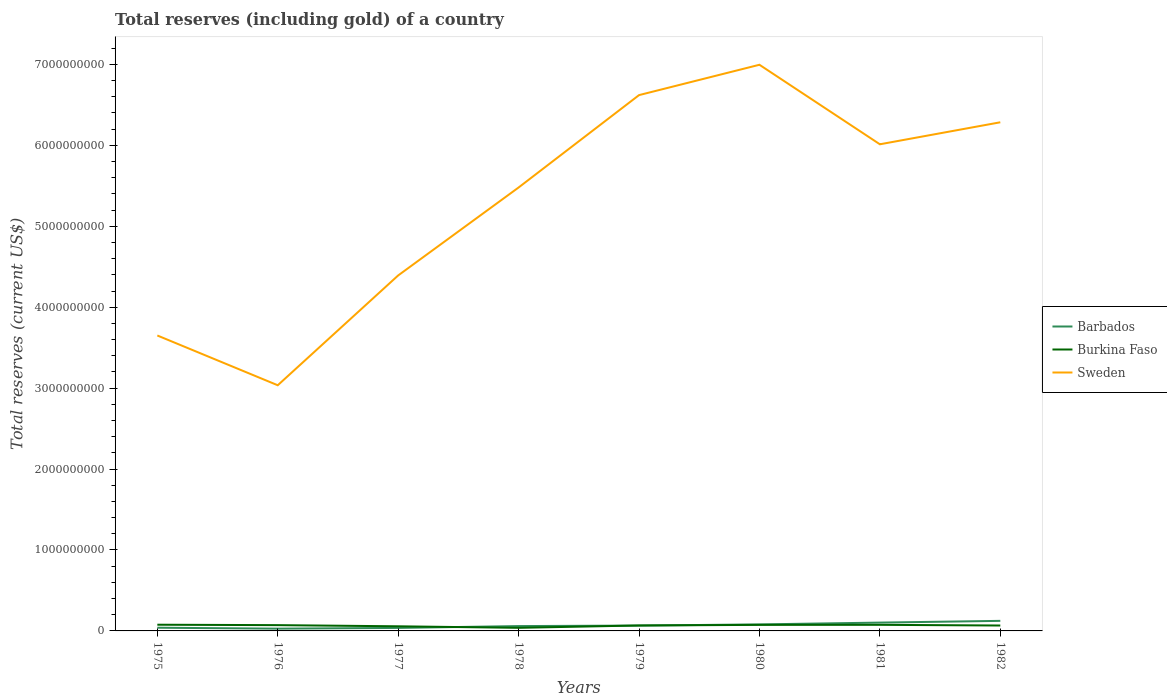Does the line corresponding to Sweden intersect with the line corresponding to Burkina Faso?
Provide a succinct answer. No. Is the number of lines equal to the number of legend labels?
Your answer should be compact. Yes. Across all years, what is the maximum total reserves (including gold) in Barbados?
Offer a very short reply. 2.80e+07. In which year was the total reserves (including gold) in Barbados maximum?
Your answer should be very brief. 1976. What is the total total reserves (including gold) in Barbados in the graph?
Your response must be concise. -8.74e+07. What is the difference between the highest and the second highest total reserves (including gold) in Sweden?
Give a very brief answer. 3.96e+09. What is the difference between the highest and the lowest total reserves (including gold) in Burkina Faso?
Your response must be concise. 6. How many lines are there?
Ensure brevity in your answer.  3. What is the difference between two consecutive major ticks on the Y-axis?
Make the answer very short. 1.00e+09. Does the graph contain any zero values?
Provide a short and direct response. No. Does the graph contain grids?
Give a very brief answer. No. What is the title of the graph?
Your response must be concise. Total reserves (including gold) of a country. What is the label or title of the X-axis?
Your answer should be very brief. Years. What is the label or title of the Y-axis?
Provide a succinct answer. Total reserves (current US$). What is the Total reserves (current US$) in Barbados in 1975?
Provide a short and direct response. 3.96e+07. What is the Total reserves (current US$) in Burkina Faso in 1975?
Your answer should be very brief. 7.65e+07. What is the Total reserves (current US$) of Sweden in 1975?
Ensure brevity in your answer.  3.65e+09. What is the Total reserves (current US$) in Barbados in 1976?
Your answer should be very brief. 2.80e+07. What is the Total reserves (current US$) of Burkina Faso in 1976?
Your answer should be compact. 7.14e+07. What is the Total reserves (current US$) of Sweden in 1976?
Ensure brevity in your answer.  3.04e+09. What is the Total reserves (current US$) of Barbados in 1977?
Keep it short and to the point. 3.70e+07. What is the Total reserves (current US$) of Burkina Faso in 1977?
Make the answer very short. 5.71e+07. What is the Total reserves (current US$) in Sweden in 1977?
Your answer should be compact. 4.39e+09. What is the Total reserves (current US$) of Barbados in 1978?
Your response must be concise. 5.98e+07. What is the Total reserves (current US$) in Burkina Faso in 1978?
Make the answer very short. 3.82e+07. What is the Total reserves (current US$) of Sweden in 1978?
Keep it short and to the point. 5.48e+09. What is the Total reserves (current US$) of Barbados in 1979?
Offer a terse response. 6.61e+07. What is the Total reserves (current US$) of Burkina Faso in 1979?
Provide a succinct answer. 6.73e+07. What is the Total reserves (current US$) in Sweden in 1979?
Offer a terse response. 6.62e+09. What is the Total reserves (current US$) of Barbados in 1980?
Your answer should be compact. 8.06e+07. What is the Total reserves (current US$) of Burkina Faso in 1980?
Provide a succinct answer. 7.48e+07. What is the Total reserves (current US$) in Sweden in 1980?
Offer a very short reply. 7.00e+09. What is the Total reserves (current US$) of Barbados in 1981?
Ensure brevity in your answer.  1.03e+08. What is the Total reserves (current US$) of Burkina Faso in 1981?
Your answer should be very brief. 7.53e+07. What is the Total reserves (current US$) in Sweden in 1981?
Make the answer very short. 6.01e+09. What is the Total reserves (current US$) of Barbados in 1982?
Ensure brevity in your answer.  1.24e+08. What is the Total reserves (current US$) of Burkina Faso in 1982?
Offer a very short reply. 6.69e+07. What is the Total reserves (current US$) in Sweden in 1982?
Your answer should be compact. 6.29e+09. Across all years, what is the maximum Total reserves (current US$) in Barbados?
Provide a succinct answer. 1.24e+08. Across all years, what is the maximum Total reserves (current US$) of Burkina Faso?
Your answer should be compact. 7.65e+07. Across all years, what is the maximum Total reserves (current US$) of Sweden?
Give a very brief answer. 7.00e+09. Across all years, what is the minimum Total reserves (current US$) of Barbados?
Offer a very short reply. 2.80e+07. Across all years, what is the minimum Total reserves (current US$) of Burkina Faso?
Make the answer very short. 3.82e+07. Across all years, what is the minimum Total reserves (current US$) of Sweden?
Provide a succinct answer. 3.04e+09. What is the total Total reserves (current US$) of Barbados in the graph?
Provide a short and direct response. 5.38e+08. What is the total Total reserves (current US$) of Burkina Faso in the graph?
Make the answer very short. 5.28e+08. What is the total Total reserves (current US$) of Sweden in the graph?
Ensure brevity in your answer.  4.25e+1. What is the difference between the Total reserves (current US$) of Barbados in 1975 and that in 1976?
Your answer should be compact. 1.16e+07. What is the difference between the Total reserves (current US$) of Burkina Faso in 1975 and that in 1976?
Your answer should be compact. 5.12e+06. What is the difference between the Total reserves (current US$) in Sweden in 1975 and that in 1976?
Keep it short and to the point. 6.15e+08. What is the difference between the Total reserves (current US$) of Barbados in 1975 and that in 1977?
Offer a very short reply. 2.57e+06. What is the difference between the Total reserves (current US$) in Burkina Faso in 1975 and that in 1977?
Your response must be concise. 1.94e+07. What is the difference between the Total reserves (current US$) in Sweden in 1975 and that in 1977?
Your response must be concise. -7.42e+08. What is the difference between the Total reserves (current US$) of Barbados in 1975 and that in 1978?
Your answer should be compact. -2.03e+07. What is the difference between the Total reserves (current US$) of Burkina Faso in 1975 and that in 1978?
Offer a terse response. 3.83e+07. What is the difference between the Total reserves (current US$) of Sweden in 1975 and that in 1978?
Provide a succinct answer. -1.83e+09. What is the difference between the Total reserves (current US$) in Barbados in 1975 and that in 1979?
Your response must be concise. -2.65e+07. What is the difference between the Total reserves (current US$) of Burkina Faso in 1975 and that in 1979?
Ensure brevity in your answer.  9.23e+06. What is the difference between the Total reserves (current US$) in Sweden in 1975 and that in 1979?
Offer a terse response. -2.97e+09. What is the difference between the Total reserves (current US$) of Barbados in 1975 and that in 1980?
Give a very brief answer. -4.10e+07. What is the difference between the Total reserves (current US$) in Burkina Faso in 1975 and that in 1980?
Offer a terse response. 1.76e+06. What is the difference between the Total reserves (current US$) of Sweden in 1975 and that in 1980?
Give a very brief answer. -3.35e+09. What is the difference between the Total reserves (current US$) of Barbados in 1975 and that in 1981?
Provide a short and direct response. -6.34e+07. What is the difference between the Total reserves (current US$) of Burkina Faso in 1975 and that in 1981?
Offer a terse response. 1.26e+06. What is the difference between the Total reserves (current US$) in Sweden in 1975 and that in 1981?
Your answer should be compact. -2.36e+09. What is the difference between the Total reserves (current US$) of Barbados in 1975 and that in 1982?
Your answer should be very brief. -8.48e+07. What is the difference between the Total reserves (current US$) in Burkina Faso in 1975 and that in 1982?
Make the answer very short. 9.68e+06. What is the difference between the Total reserves (current US$) in Sweden in 1975 and that in 1982?
Offer a terse response. -2.63e+09. What is the difference between the Total reserves (current US$) in Barbados in 1976 and that in 1977?
Ensure brevity in your answer.  -9.03e+06. What is the difference between the Total reserves (current US$) in Burkina Faso in 1976 and that in 1977?
Your answer should be very brief. 1.43e+07. What is the difference between the Total reserves (current US$) in Sweden in 1976 and that in 1977?
Ensure brevity in your answer.  -1.36e+09. What is the difference between the Total reserves (current US$) of Barbados in 1976 and that in 1978?
Your response must be concise. -3.19e+07. What is the difference between the Total reserves (current US$) in Burkina Faso in 1976 and that in 1978?
Provide a succinct answer. 3.32e+07. What is the difference between the Total reserves (current US$) of Sweden in 1976 and that in 1978?
Ensure brevity in your answer.  -2.44e+09. What is the difference between the Total reserves (current US$) of Barbados in 1976 and that in 1979?
Give a very brief answer. -3.81e+07. What is the difference between the Total reserves (current US$) in Burkina Faso in 1976 and that in 1979?
Your answer should be very brief. 4.11e+06. What is the difference between the Total reserves (current US$) in Sweden in 1976 and that in 1979?
Offer a very short reply. -3.59e+09. What is the difference between the Total reserves (current US$) of Barbados in 1976 and that in 1980?
Make the answer very short. -5.26e+07. What is the difference between the Total reserves (current US$) of Burkina Faso in 1976 and that in 1980?
Offer a very short reply. -3.37e+06. What is the difference between the Total reserves (current US$) in Sweden in 1976 and that in 1980?
Give a very brief answer. -3.96e+09. What is the difference between the Total reserves (current US$) in Barbados in 1976 and that in 1981?
Your response must be concise. -7.50e+07. What is the difference between the Total reserves (current US$) of Burkina Faso in 1976 and that in 1981?
Provide a short and direct response. -3.87e+06. What is the difference between the Total reserves (current US$) in Sweden in 1976 and that in 1981?
Your answer should be compact. -2.98e+09. What is the difference between the Total reserves (current US$) of Barbados in 1976 and that in 1982?
Ensure brevity in your answer.  -9.64e+07. What is the difference between the Total reserves (current US$) in Burkina Faso in 1976 and that in 1982?
Ensure brevity in your answer.  4.55e+06. What is the difference between the Total reserves (current US$) in Sweden in 1976 and that in 1982?
Provide a succinct answer. -3.25e+09. What is the difference between the Total reserves (current US$) of Barbados in 1977 and that in 1978?
Offer a very short reply. -2.28e+07. What is the difference between the Total reserves (current US$) of Burkina Faso in 1977 and that in 1978?
Your answer should be compact. 1.89e+07. What is the difference between the Total reserves (current US$) in Sweden in 1977 and that in 1978?
Ensure brevity in your answer.  -1.09e+09. What is the difference between the Total reserves (current US$) of Barbados in 1977 and that in 1979?
Offer a very short reply. -2.91e+07. What is the difference between the Total reserves (current US$) in Burkina Faso in 1977 and that in 1979?
Keep it short and to the point. -1.02e+07. What is the difference between the Total reserves (current US$) of Sweden in 1977 and that in 1979?
Your answer should be compact. -2.23e+09. What is the difference between the Total reserves (current US$) of Barbados in 1977 and that in 1980?
Your response must be concise. -4.36e+07. What is the difference between the Total reserves (current US$) in Burkina Faso in 1977 and that in 1980?
Provide a succinct answer. -1.76e+07. What is the difference between the Total reserves (current US$) in Sweden in 1977 and that in 1980?
Offer a terse response. -2.60e+09. What is the difference between the Total reserves (current US$) in Barbados in 1977 and that in 1981?
Offer a terse response. -6.60e+07. What is the difference between the Total reserves (current US$) of Burkina Faso in 1977 and that in 1981?
Give a very brief answer. -1.81e+07. What is the difference between the Total reserves (current US$) of Sweden in 1977 and that in 1981?
Ensure brevity in your answer.  -1.62e+09. What is the difference between the Total reserves (current US$) in Barbados in 1977 and that in 1982?
Offer a terse response. -8.74e+07. What is the difference between the Total reserves (current US$) of Burkina Faso in 1977 and that in 1982?
Offer a terse response. -9.73e+06. What is the difference between the Total reserves (current US$) of Sweden in 1977 and that in 1982?
Your answer should be very brief. -1.89e+09. What is the difference between the Total reserves (current US$) of Barbados in 1978 and that in 1979?
Provide a succinct answer. -6.28e+06. What is the difference between the Total reserves (current US$) of Burkina Faso in 1978 and that in 1979?
Offer a very short reply. -2.91e+07. What is the difference between the Total reserves (current US$) of Sweden in 1978 and that in 1979?
Your response must be concise. -1.14e+09. What is the difference between the Total reserves (current US$) in Barbados in 1978 and that in 1980?
Offer a terse response. -2.07e+07. What is the difference between the Total reserves (current US$) in Burkina Faso in 1978 and that in 1980?
Ensure brevity in your answer.  -3.66e+07. What is the difference between the Total reserves (current US$) in Sweden in 1978 and that in 1980?
Make the answer very short. -1.52e+09. What is the difference between the Total reserves (current US$) of Barbados in 1978 and that in 1981?
Keep it short and to the point. -4.31e+07. What is the difference between the Total reserves (current US$) of Burkina Faso in 1978 and that in 1981?
Provide a short and direct response. -3.71e+07. What is the difference between the Total reserves (current US$) in Sweden in 1978 and that in 1981?
Offer a very short reply. -5.34e+08. What is the difference between the Total reserves (current US$) of Barbados in 1978 and that in 1982?
Your response must be concise. -6.45e+07. What is the difference between the Total reserves (current US$) of Burkina Faso in 1978 and that in 1982?
Provide a short and direct response. -2.87e+07. What is the difference between the Total reserves (current US$) of Sweden in 1978 and that in 1982?
Keep it short and to the point. -8.06e+08. What is the difference between the Total reserves (current US$) of Barbados in 1979 and that in 1980?
Your response must be concise. -1.45e+07. What is the difference between the Total reserves (current US$) of Burkina Faso in 1979 and that in 1980?
Your answer should be compact. -7.48e+06. What is the difference between the Total reserves (current US$) in Sweden in 1979 and that in 1980?
Your answer should be very brief. -3.75e+08. What is the difference between the Total reserves (current US$) of Barbados in 1979 and that in 1981?
Your answer should be very brief. -3.68e+07. What is the difference between the Total reserves (current US$) in Burkina Faso in 1979 and that in 1981?
Make the answer very short. -7.98e+06. What is the difference between the Total reserves (current US$) of Sweden in 1979 and that in 1981?
Offer a very short reply. 6.08e+08. What is the difference between the Total reserves (current US$) of Barbados in 1979 and that in 1982?
Your answer should be compact. -5.83e+07. What is the difference between the Total reserves (current US$) of Burkina Faso in 1979 and that in 1982?
Ensure brevity in your answer.  4.41e+05. What is the difference between the Total reserves (current US$) in Sweden in 1979 and that in 1982?
Offer a very short reply. 3.36e+08. What is the difference between the Total reserves (current US$) of Barbados in 1980 and that in 1981?
Your answer should be compact. -2.24e+07. What is the difference between the Total reserves (current US$) of Burkina Faso in 1980 and that in 1981?
Offer a very short reply. -4.99e+05. What is the difference between the Total reserves (current US$) in Sweden in 1980 and that in 1981?
Your answer should be compact. 9.83e+08. What is the difference between the Total reserves (current US$) in Barbados in 1980 and that in 1982?
Provide a short and direct response. -4.38e+07. What is the difference between the Total reserves (current US$) of Burkina Faso in 1980 and that in 1982?
Offer a very short reply. 7.92e+06. What is the difference between the Total reserves (current US$) in Sweden in 1980 and that in 1982?
Keep it short and to the point. 7.11e+08. What is the difference between the Total reserves (current US$) in Barbados in 1981 and that in 1982?
Offer a very short reply. -2.14e+07. What is the difference between the Total reserves (current US$) in Burkina Faso in 1981 and that in 1982?
Offer a very short reply. 8.42e+06. What is the difference between the Total reserves (current US$) in Sweden in 1981 and that in 1982?
Provide a short and direct response. -2.72e+08. What is the difference between the Total reserves (current US$) in Barbados in 1975 and the Total reserves (current US$) in Burkina Faso in 1976?
Ensure brevity in your answer.  -3.18e+07. What is the difference between the Total reserves (current US$) in Barbados in 1975 and the Total reserves (current US$) in Sweden in 1976?
Keep it short and to the point. -3.00e+09. What is the difference between the Total reserves (current US$) in Burkina Faso in 1975 and the Total reserves (current US$) in Sweden in 1976?
Provide a succinct answer. -2.96e+09. What is the difference between the Total reserves (current US$) in Barbados in 1975 and the Total reserves (current US$) in Burkina Faso in 1977?
Offer a very short reply. -1.76e+07. What is the difference between the Total reserves (current US$) of Barbados in 1975 and the Total reserves (current US$) of Sweden in 1977?
Provide a succinct answer. -4.35e+09. What is the difference between the Total reserves (current US$) of Burkina Faso in 1975 and the Total reserves (current US$) of Sweden in 1977?
Provide a short and direct response. -4.32e+09. What is the difference between the Total reserves (current US$) of Barbados in 1975 and the Total reserves (current US$) of Burkina Faso in 1978?
Keep it short and to the point. 1.36e+06. What is the difference between the Total reserves (current US$) of Barbados in 1975 and the Total reserves (current US$) of Sweden in 1978?
Keep it short and to the point. -5.44e+09. What is the difference between the Total reserves (current US$) in Burkina Faso in 1975 and the Total reserves (current US$) in Sweden in 1978?
Make the answer very short. -5.40e+09. What is the difference between the Total reserves (current US$) in Barbados in 1975 and the Total reserves (current US$) in Burkina Faso in 1979?
Give a very brief answer. -2.77e+07. What is the difference between the Total reserves (current US$) in Barbados in 1975 and the Total reserves (current US$) in Sweden in 1979?
Your response must be concise. -6.58e+09. What is the difference between the Total reserves (current US$) in Burkina Faso in 1975 and the Total reserves (current US$) in Sweden in 1979?
Provide a succinct answer. -6.54e+09. What is the difference between the Total reserves (current US$) of Barbados in 1975 and the Total reserves (current US$) of Burkina Faso in 1980?
Provide a succinct answer. -3.52e+07. What is the difference between the Total reserves (current US$) of Barbados in 1975 and the Total reserves (current US$) of Sweden in 1980?
Offer a very short reply. -6.96e+09. What is the difference between the Total reserves (current US$) of Burkina Faso in 1975 and the Total reserves (current US$) of Sweden in 1980?
Provide a short and direct response. -6.92e+09. What is the difference between the Total reserves (current US$) in Barbados in 1975 and the Total reserves (current US$) in Burkina Faso in 1981?
Your answer should be compact. -3.57e+07. What is the difference between the Total reserves (current US$) of Barbados in 1975 and the Total reserves (current US$) of Sweden in 1981?
Keep it short and to the point. -5.97e+09. What is the difference between the Total reserves (current US$) of Burkina Faso in 1975 and the Total reserves (current US$) of Sweden in 1981?
Your response must be concise. -5.94e+09. What is the difference between the Total reserves (current US$) in Barbados in 1975 and the Total reserves (current US$) in Burkina Faso in 1982?
Provide a succinct answer. -2.73e+07. What is the difference between the Total reserves (current US$) in Barbados in 1975 and the Total reserves (current US$) in Sweden in 1982?
Provide a short and direct response. -6.25e+09. What is the difference between the Total reserves (current US$) in Burkina Faso in 1975 and the Total reserves (current US$) in Sweden in 1982?
Your answer should be compact. -6.21e+09. What is the difference between the Total reserves (current US$) in Barbados in 1976 and the Total reserves (current US$) in Burkina Faso in 1977?
Provide a succinct answer. -2.92e+07. What is the difference between the Total reserves (current US$) in Barbados in 1976 and the Total reserves (current US$) in Sweden in 1977?
Provide a short and direct response. -4.36e+09. What is the difference between the Total reserves (current US$) of Burkina Faso in 1976 and the Total reserves (current US$) of Sweden in 1977?
Make the answer very short. -4.32e+09. What is the difference between the Total reserves (current US$) in Barbados in 1976 and the Total reserves (current US$) in Burkina Faso in 1978?
Your answer should be compact. -1.02e+07. What is the difference between the Total reserves (current US$) in Barbados in 1976 and the Total reserves (current US$) in Sweden in 1978?
Your answer should be compact. -5.45e+09. What is the difference between the Total reserves (current US$) in Burkina Faso in 1976 and the Total reserves (current US$) in Sweden in 1978?
Your answer should be compact. -5.41e+09. What is the difference between the Total reserves (current US$) of Barbados in 1976 and the Total reserves (current US$) of Burkina Faso in 1979?
Ensure brevity in your answer.  -3.93e+07. What is the difference between the Total reserves (current US$) in Barbados in 1976 and the Total reserves (current US$) in Sweden in 1979?
Keep it short and to the point. -6.59e+09. What is the difference between the Total reserves (current US$) of Burkina Faso in 1976 and the Total reserves (current US$) of Sweden in 1979?
Offer a terse response. -6.55e+09. What is the difference between the Total reserves (current US$) in Barbados in 1976 and the Total reserves (current US$) in Burkina Faso in 1980?
Make the answer very short. -4.68e+07. What is the difference between the Total reserves (current US$) of Barbados in 1976 and the Total reserves (current US$) of Sweden in 1980?
Your response must be concise. -6.97e+09. What is the difference between the Total reserves (current US$) of Burkina Faso in 1976 and the Total reserves (current US$) of Sweden in 1980?
Provide a short and direct response. -6.92e+09. What is the difference between the Total reserves (current US$) of Barbados in 1976 and the Total reserves (current US$) of Burkina Faso in 1981?
Give a very brief answer. -4.73e+07. What is the difference between the Total reserves (current US$) of Barbados in 1976 and the Total reserves (current US$) of Sweden in 1981?
Offer a very short reply. -5.99e+09. What is the difference between the Total reserves (current US$) of Burkina Faso in 1976 and the Total reserves (current US$) of Sweden in 1981?
Your answer should be compact. -5.94e+09. What is the difference between the Total reserves (current US$) of Barbados in 1976 and the Total reserves (current US$) of Burkina Faso in 1982?
Keep it short and to the point. -3.89e+07. What is the difference between the Total reserves (current US$) of Barbados in 1976 and the Total reserves (current US$) of Sweden in 1982?
Keep it short and to the point. -6.26e+09. What is the difference between the Total reserves (current US$) in Burkina Faso in 1976 and the Total reserves (current US$) in Sweden in 1982?
Provide a succinct answer. -6.21e+09. What is the difference between the Total reserves (current US$) of Barbados in 1977 and the Total reserves (current US$) of Burkina Faso in 1978?
Ensure brevity in your answer.  -1.21e+06. What is the difference between the Total reserves (current US$) of Barbados in 1977 and the Total reserves (current US$) of Sweden in 1978?
Your answer should be compact. -5.44e+09. What is the difference between the Total reserves (current US$) in Burkina Faso in 1977 and the Total reserves (current US$) in Sweden in 1978?
Provide a short and direct response. -5.42e+09. What is the difference between the Total reserves (current US$) of Barbados in 1977 and the Total reserves (current US$) of Burkina Faso in 1979?
Your response must be concise. -3.03e+07. What is the difference between the Total reserves (current US$) in Barbados in 1977 and the Total reserves (current US$) in Sweden in 1979?
Ensure brevity in your answer.  -6.58e+09. What is the difference between the Total reserves (current US$) of Burkina Faso in 1977 and the Total reserves (current US$) of Sweden in 1979?
Your answer should be compact. -6.56e+09. What is the difference between the Total reserves (current US$) of Barbados in 1977 and the Total reserves (current US$) of Burkina Faso in 1980?
Your answer should be compact. -3.78e+07. What is the difference between the Total reserves (current US$) in Barbados in 1977 and the Total reserves (current US$) in Sweden in 1980?
Provide a succinct answer. -6.96e+09. What is the difference between the Total reserves (current US$) of Burkina Faso in 1977 and the Total reserves (current US$) of Sweden in 1980?
Make the answer very short. -6.94e+09. What is the difference between the Total reserves (current US$) of Barbados in 1977 and the Total reserves (current US$) of Burkina Faso in 1981?
Ensure brevity in your answer.  -3.83e+07. What is the difference between the Total reserves (current US$) of Barbados in 1977 and the Total reserves (current US$) of Sweden in 1981?
Make the answer very short. -5.98e+09. What is the difference between the Total reserves (current US$) in Burkina Faso in 1977 and the Total reserves (current US$) in Sweden in 1981?
Make the answer very short. -5.96e+09. What is the difference between the Total reserves (current US$) in Barbados in 1977 and the Total reserves (current US$) in Burkina Faso in 1982?
Your response must be concise. -2.99e+07. What is the difference between the Total reserves (current US$) in Barbados in 1977 and the Total reserves (current US$) in Sweden in 1982?
Provide a succinct answer. -6.25e+09. What is the difference between the Total reserves (current US$) in Burkina Faso in 1977 and the Total reserves (current US$) in Sweden in 1982?
Give a very brief answer. -6.23e+09. What is the difference between the Total reserves (current US$) of Barbados in 1978 and the Total reserves (current US$) of Burkina Faso in 1979?
Offer a terse response. -7.48e+06. What is the difference between the Total reserves (current US$) of Barbados in 1978 and the Total reserves (current US$) of Sweden in 1979?
Offer a terse response. -6.56e+09. What is the difference between the Total reserves (current US$) of Burkina Faso in 1978 and the Total reserves (current US$) of Sweden in 1979?
Your answer should be compact. -6.58e+09. What is the difference between the Total reserves (current US$) in Barbados in 1978 and the Total reserves (current US$) in Burkina Faso in 1980?
Make the answer very short. -1.50e+07. What is the difference between the Total reserves (current US$) in Barbados in 1978 and the Total reserves (current US$) in Sweden in 1980?
Keep it short and to the point. -6.94e+09. What is the difference between the Total reserves (current US$) of Burkina Faso in 1978 and the Total reserves (current US$) of Sweden in 1980?
Provide a short and direct response. -6.96e+09. What is the difference between the Total reserves (current US$) in Barbados in 1978 and the Total reserves (current US$) in Burkina Faso in 1981?
Offer a terse response. -1.55e+07. What is the difference between the Total reserves (current US$) in Barbados in 1978 and the Total reserves (current US$) in Sweden in 1981?
Offer a terse response. -5.95e+09. What is the difference between the Total reserves (current US$) of Burkina Faso in 1978 and the Total reserves (current US$) of Sweden in 1981?
Offer a very short reply. -5.98e+09. What is the difference between the Total reserves (current US$) in Barbados in 1978 and the Total reserves (current US$) in Burkina Faso in 1982?
Give a very brief answer. -7.04e+06. What is the difference between the Total reserves (current US$) of Barbados in 1978 and the Total reserves (current US$) of Sweden in 1982?
Offer a terse response. -6.23e+09. What is the difference between the Total reserves (current US$) of Burkina Faso in 1978 and the Total reserves (current US$) of Sweden in 1982?
Your answer should be very brief. -6.25e+09. What is the difference between the Total reserves (current US$) in Barbados in 1979 and the Total reserves (current US$) in Burkina Faso in 1980?
Make the answer very short. -8.67e+06. What is the difference between the Total reserves (current US$) of Barbados in 1979 and the Total reserves (current US$) of Sweden in 1980?
Make the answer very short. -6.93e+09. What is the difference between the Total reserves (current US$) in Burkina Faso in 1979 and the Total reserves (current US$) in Sweden in 1980?
Your answer should be very brief. -6.93e+09. What is the difference between the Total reserves (current US$) in Barbados in 1979 and the Total reserves (current US$) in Burkina Faso in 1981?
Your answer should be very brief. -9.17e+06. What is the difference between the Total reserves (current US$) in Barbados in 1979 and the Total reserves (current US$) in Sweden in 1981?
Offer a terse response. -5.95e+09. What is the difference between the Total reserves (current US$) of Burkina Faso in 1979 and the Total reserves (current US$) of Sweden in 1981?
Offer a terse response. -5.95e+09. What is the difference between the Total reserves (current US$) in Barbados in 1979 and the Total reserves (current US$) in Burkina Faso in 1982?
Make the answer very short. -7.56e+05. What is the difference between the Total reserves (current US$) of Barbados in 1979 and the Total reserves (current US$) of Sweden in 1982?
Make the answer very short. -6.22e+09. What is the difference between the Total reserves (current US$) of Burkina Faso in 1979 and the Total reserves (current US$) of Sweden in 1982?
Provide a succinct answer. -6.22e+09. What is the difference between the Total reserves (current US$) of Barbados in 1980 and the Total reserves (current US$) of Burkina Faso in 1981?
Your answer should be very brief. 5.28e+06. What is the difference between the Total reserves (current US$) in Barbados in 1980 and the Total reserves (current US$) in Sweden in 1981?
Make the answer very short. -5.93e+09. What is the difference between the Total reserves (current US$) of Burkina Faso in 1980 and the Total reserves (current US$) of Sweden in 1981?
Make the answer very short. -5.94e+09. What is the difference between the Total reserves (current US$) in Barbados in 1980 and the Total reserves (current US$) in Burkina Faso in 1982?
Offer a very short reply. 1.37e+07. What is the difference between the Total reserves (current US$) of Barbados in 1980 and the Total reserves (current US$) of Sweden in 1982?
Ensure brevity in your answer.  -6.20e+09. What is the difference between the Total reserves (current US$) of Burkina Faso in 1980 and the Total reserves (current US$) of Sweden in 1982?
Your answer should be compact. -6.21e+09. What is the difference between the Total reserves (current US$) in Barbados in 1981 and the Total reserves (current US$) in Burkina Faso in 1982?
Your answer should be very brief. 3.61e+07. What is the difference between the Total reserves (current US$) in Barbados in 1981 and the Total reserves (current US$) in Sweden in 1982?
Ensure brevity in your answer.  -6.18e+09. What is the difference between the Total reserves (current US$) of Burkina Faso in 1981 and the Total reserves (current US$) of Sweden in 1982?
Give a very brief answer. -6.21e+09. What is the average Total reserves (current US$) in Barbados per year?
Offer a terse response. 6.73e+07. What is the average Total reserves (current US$) of Burkina Faso per year?
Offer a terse response. 6.60e+07. What is the average Total reserves (current US$) in Sweden per year?
Make the answer very short. 5.31e+09. In the year 1975, what is the difference between the Total reserves (current US$) of Barbados and Total reserves (current US$) of Burkina Faso?
Make the answer very short. -3.70e+07. In the year 1975, what is the difference between the Total reserves (current US$) in Barbados and Total reserves (current US$) in Sweden?
Your answer should be compact. -3.61e+09. In the year 1975, what is the difference between the Total reserves (current US$) of Burkina Faso and Total reserves (current US$) of Sweden?
Provide a succinct answer. -3.57e+09. In the year 1976, what is the difference between the Total reserves (current US$) of Barbados and Total reserves (current US$) of Burkina Faso?
Offer a terse response. -4.34e+07. In the year 1976, what is the difference between the Total reserves (current US$) of Barbados and Total reserves (current US$) of Sweden?
Offer a terse response. -3.01e+09. In the year 1976, what is the difference between the Total reserves (current US$) in Burkina Faso and Total reserves (current US$) in Sweden?
Ensure brevity in your answer.  -2.96e+09. In the year 1977, what is the difference between the Total reserves (current US$) in Barbados and Total reserves (current US$) in Burkina Faso?
Offer a terse response. -2.01e+07. In the year 1977, what is the difference between the Total reserves (current US$) in Barbados and Total reserves (current US$) in Sweden?
Offer a terse response. -4.36e+09. In the year 1977, what is the difference between the Total reserves (current US$) of Burkina Faso and Total reserves (current US$) of Sweden?
Your response must be concise. -4.34e+09. In the year 1978, what is the difference between the Total reserves (current US$) in Barbados and Total reserves (current US$) in Burkina Faso?
Keep it short and to the point. 2.16e+07. In the year 1978, what is the difference between the Total reserves (current US$) of Barbados and Total reserves (current US$) of Sweden?
Your response must be concise. -5.42e+09. In the year 1978, what is the difference between the Total reserves (current US$) of Burkina Faso and Total reserves (current US$) of Sweden?
Your response must be concise. -5.44e+09. In the year 1979, what is the difference between the Total reserves (current US$) of Barbados and Total reserves (current US$) of Burkina Faso?
Ensure brevity in your answer.  -1.20e+06. In the year 1979, what is the difference between the Total reserves (current US$) of Barbados and Total reserves (current US$) of Sweden?
Your answer should be compact. -6.55e+09. In the year 1979, what is the difference between the Total reserves (current US$) of Burkina Faso and Total reserves (current US$) of Sweden?
Your response must be concise. -6.55e+09. In the year 1980, what is the difference between the Total reserves (current US$) in Barbados and Total reserves (current US$) in Burkina Faso?
Give a very brief answer. 5.78e+06. In the year 1980, what is the difference between the Total reserves (current US$) of Barbados and Total reserves (current US$) of Sweden?
Your response must be concise. -6.92e+09. In the year 1980, what is the difference between the Total reserves (current US$) in Burkina Faso and Total reserves (current US$) in Sweden?
Provide a succinct answer. -6.92e+09. In the year 1981, what is the difference between the Total reserves (current US$) of Barbados and Total reserves (current US$) of Burkina Faso?
Make the answer very short. 2.77e+07. In the year 1981, what is the difference between the Total reserves (current US$) in Barbados and Total reserves (current US$) in Sweden?
Offer a very short reply. -5.91e+09. In the year 1981, what is the difference between the Total reserves (current US$) of Burkina Faso and Total reserves (current US$) of Sweden?
Your answer should be very brief. -5.94e+09. In the year 1982, what is the difference between the Total reserves (current US$) in Barbados and Total reserves (current US$) in Burkina Faso?
Offer a very short reply. 5.75e+07. In the year 1982, what is the difference between the Total reserves (current US$) of Barbados and Total reserves (current US$) of Sweden?
Keep it short and to the point. -6.16e+09. In the year 1982, what is the difference between the Total reserves (current US$) in Burkina Faso and Total reserves (current US$) in Sweden?
Offer a very short reply. -6.22e+09. What is the ratio of the Total reserves (current US$) of Barbados in 1975 to that in 1976?
Your response must be concise. 1.41. What is the ratio of the Total reserves (current US$) in Burkina Faso in 1975 to that in 1976?
Your answer should be very brief. 1.07. What is the ratio of the Total reserves (current US$) of Sweden in 1975 to that in 1976?
Give a very brief answer. 1.2. What is the ratio of the Total reserves (current US$) in Barbados in 1975 to that in 1977?
Offer a very short reply. 1.07. What is the ratio of the Total reserves (current US$) of Burkina Faso in 1975 to that in 1977?
Provide a succinct answer. 1.34. What is the ratio of the Total reserves (current US$) of Sweden in 1975 to that in 1977?
Offer a very short reply. 0.83. What is the ratio of the Total reserves (current US$) in Barbados in 1975 to that in 1978?
Your answer should be very brief. 0.66. What is the ratio of the Total reserves (current US$) of Burkina Faso in 1975 to that in 1978?
Provide a short and direct response. 2. What is the ratio of the Total reserves (current US$) of Sweden in 1975 to that in 1978?
Your answer should be very brief. 0.67. What is the ratio of the Total reserves (current US$) of Barbados in 1975 to that in 1979?
Make the answer very short. 0.6. What is the ratio of the Total reserves (current US$) in Burkina Faso in 1975 to that in 1979?
Ensure brevity in your answer.  1.14. What is the ratio of the Total reserves (current US$) of Sweden in 1975 to that in 1979?
Offer a very short reply. 0.55. What is the ratio of the Total reserves (current US$) in Barbados in 1975 to that in 1980?
Make the answer very short. 0.49. What is the ratio of the Total reserves (current US$) of Burkina Faso in 1975 to that in 1980?
Offer a terse response. 1.02. What is the ratio of the Total reserves (current US$) of Sweden in 1975 to that in 1980?
Offer a very short reply. 0.52. What is the ratio of the Total reserves (current US$) of Barbados in 1975 to that in 1981?
Offer a very short reply. 0.38. What is the ratio of the Total reserves (current US$) in Burkina Faso in 1975 to that in 1981?
Keep it short and to the point. 1.02. What is the ratio of the Total reserves (current US$) in Sweden in 1975 to that in 1981?
Offer a very short reply. 0.61. What is the ratio of the Total reserves (current US$) of Barbados in 1975 to that in 1982?
Make the answer very short. 0.32. What is the ratio of the Total reserves (current US$) of Burkina Faso in 1975 to that in 1982?
Offer a very short reply. 1.14. What is the ratio of the Total reserves (current US$) of Sweden in 1975 to that in 1982?
Keep it short and to the point. 0.58. What is the ratio of the Total reserves (current US$) in Barbados in 1976 to that in 1977?
Ensure brevity in your answer.  0.76. What is the ratio of the Total reserves (current US$) of Burkina Faso in 1976 to that in 1977?
Provide a short and direct response. 1.25. What is the ratio of the Total reserves (current US$) of Sweden in 1976 to that in 1977?
Your answer should be compact. 0.69. What is the ratio of the Total reserves (current US$) of Barbados in 1976 to that in 1978?
Make the answer very short. 0.47. What is the ratio of the Total reserves (current US$) in Burkina Faso in 1976 to that in 1978?
Ensure brevity in your answer.  1.87. What is the ratio of the Total reserves (current US$) of Sweden in 1976 to that in 1978?
Give a very brief answer. 0.55. What is the ratio of the Total reserves (current US$) of Barbados in 1976 to that in 1979?
Offer a terse response. 0.42. What is the ratio of the Total reserves (current US$) of Burkina Faso in 1976 to that in 1979?
Provide a succinct answer. 1.06. What is the ratio of the Total reserves (current US$) in Sweden in 1976 to that in 1979?
Offer a very short reply. 0.46. What is the ratio of the Total reserves (current US$) of Barbados in 1976 to that in 1980?
Your response must be concise. 0.35. What is the ratio of the Total reserves (current US$) in Burkina Faso in 1976 to that in 1980?
Your response must be concise. 0.95. What is the ratio of the Total reserves (current US$) of Sweden in 1976 to that in 1980?
Make the answer very short. 0.43. What is the ratio of the Total reserves (current US$) in Barbados in 1976 to that in 1981?
Ensure brevity in your answer.  0.27. What is the ratio of the Total reserves (current US$) in Burkina Faso in 1976 to that in 1981?
Ensure brevity in your answer.  0.95. What is the ratio of the Total reserves (current US$) in Sweden in 1976 to that in 1981?
Provide a short and direct response. 0.5. What is the ratio of the Total reserves (current US$) of Barbados in 1976 to that in 1982?
Keep it short and to the point. 0.23. What is the ratio of the Total reserves (current US$) in Burkina Faso in 1976 to that in 1982?
Your answer should be compact. 1.07. What is the ratio of the Total reserves (current US$) in Sweden in 1976 to that in 1982?
Offer a terse response. 0.48. What is the ratio of the Total reserves (current US$) of Barbados in 1977 to that in 1978?
Ensure brevity in your answer.  0.62. What is the ratio of the Total reserves (current US$) of Burkina Faso in 1977 to that in 1978?
Offer a terse response. 1.5. What is the ratio of the Total reserves (current US$) in Sweden in 1977 to that in 1978?
Ensure brevity in your answer.  0.8. What is the ratio of the Total reserves (current US$) of Barbados in 1977 to that in 1979?
Your answer should be very brief. 0.56. What is the ratio of the Total reserves (current US$) in Burkina Faso in 1977 to that in 1979?
Your answer should be compact. 0.85. What is the ratio of the Total reserves (current US$) of Sweden in 1977 to that in 1979?
Offer a terse response. 0.66. What is the ratio of the Total reserves (current US$) of Barbados in 1977 to that in 1980?
Provide a short and direct response. 0.46. What is the ratio of the Total reserves (current US$) in Burkina Faso in 1977 to that in 1980?
Offer a terse response. 0.76. What is the ratio of the Total reserves (current US$) in Sweden in 1977 to that in 1980?
Give a very brief answer. 0.63. What is the ratio of the Total reserves (current US$) of Barbados in 1977 to that in 1981?
Make the answer very short. 0.36. What is the ratio of the Total reserves (current US$) of Burkina Faso in 1977 to that in 1981?
Keep it short and to the point. 0.76. What is the ratio of the Total reserves (current US$) in Sweden in 1977 to that in 1981?
Offer a very short reply. 0.73. What is the ratio of the Total reserves (current US$) of Barbados in 1977 to that in 1982?
Make the answer very short. 0.3. What is the ratio of the Total reserves (current US$) in Burkina Faso in 1977 to that in 1982?
Give a very brief answer. 0.85. What is the ratio of the Total reserves (current US$) in Sweden in 1977 to that in 1982?
Offer a very short reply. 0.7. What is the ratio of the Total reserves (current US$) in Barbados in 1978 to that in 1979?
Offer a very short reply. 0.91. What is the ratio of the Total reserves (current US$) of Burkina Faso in 1978 to that in 1979?
Your answer should be compact. 0.57. What is the ratio of the Total reserves (current US$) in Sweden in 1978 to that in 1979?
Ensure brevity in your answer.  0.83. What is the ratio of the Total reserves (current US$) of Barbados in 1978 to that in 1980?
Provide a succinct answer. 0.74. What is the ratio of the Total reserves (current US$) of Burkina Faso in 1978 to that in 1980?
Ensure brevity in your answer.  0.51. What is the ratio of the Total reserves (current US$) in Sweden in 1978 to that in 1980?
Your response must be concise. 0.78. What is the ratio of the Total reserves (current US$) of Barbados in 1978 to that in 1981?
Give a very brief answer. 0.58. What is the ratio of the Total reserves (current US$) of Burkina Faso in 1978 to that in 1981?
Provide a short and direct response. 0.51. What is the ratio of the Total reserves (current US$) of Sweden in 1978 to that in 1981?
Your answer should be compact. 0.91. What is the ratio of the Total reserves (current US$) of Barbados in 1978 to that in 1982?
Your answer should be compact. 0.48. What is the ratio of the Total reserves (current US$) in Burkina Faso in 1978 to that in 1982?
Provide a succinct answer. 0.57. What is the ratio of the Total reserves (current US$) of Sweden in 1978 to that in 1982?
Ensure brevity in your answer.  0.87. What is the ratio of the Total reserves (current US$) in Barbados in 1979 to that in 1980?
Provide a short and direct response. 0.82. What is the ratio of the Total reserves (current US$) in Sweden in 1979 to that in 1980?
Provide a short and direct response. 0.95. What is the ratio of the Total reserves (current US$) of Barbados in 1979 to that in 1981?
Make the answer very short. 0.64. What is the ratio of the Total reserves (current US$) of Burkina Faso in 1979 to that in 1981?
Make the answer very short. 0.89. What is the ratio of the Total reserves (current US$) of Sweden in 1979 to that in 1981?
Your answer should be very brief. 1.1. What is the ratio of the Total reserves (current US$) in Barbados in 1979 to that in 1982?
Offer a very short reply. 0.53. What is the ratio of the Total reserves (current US$) in Burkina Faso in 1979 to that in 1982?
Give a very brief answer. 1.01. What is the ratio of the Total reserves (current US$) in Sweden in 1979 to that in 1982?
Give a very brief answer. 1.05. What is the ratio of the Total reserves (current US$) of Barbados in 1980 to that in 1981?
Your answer should be compact. 0.78. What is the ratio of the Total reserves (current US$) of Burkina Faso in 1980 to that in 1981?
Provide a succinct answer. 0.99. What is the ratio of the Total reserves (current US$) of Sweden in 1980 to that in 1981?
Your response must be concise. 1.16. What is the ratio of the Total reserves (current US$) in Barbados in 1980 to that in 1982?
Your response must be concise. 0.65. What is the ratio of the Total reserves (current US$) in Burkina Faso in 1980 to that in 1982?
Make the answer very short. 1.12. What is the ratio of the Total reserves (current US$) of Sweden in 1980 to that in 1982?
Keep it short and to the point. 1.11. What is the ratio of the Total reserves (current US$) of Barbados in 1981 to that in 1982?
Keep it short and to the point. 0.83. What is the ratio of the Total reserves (current US$) in Burkina Faso in 1981 to that in 1982?
Give a very brief answer. 1.13. What is the ratio of the Total reserves (current US$) of Sweden in 1981 to that in 1982?
Offer a very short reply. 0.96. What is the difference between the highest and the second highest Total reserves (current US$) in Barbados?
Provide a short and direct response. 2.14e+07. What is the difference between the highest and the second highest Total reserves (current US$) of Burkina Faso?
Provide a short and direct response. 1.26e+06. What is the difference between the highest and the second highest Total reserves (current US$) of Sweden?
Offer a very short reply. 3.75e+08. What is the difference between the highest and the lowest Total reserves (current US$) of Barbados?
Provide a succinct answer. 9.64e+07. What is the difference between the highest and the lowest Total reserves (current US$) in Burkina Faso?
Give a very brief answer. 3.83e+07. What is the difference between the highest and the lowest Total reserves (current US$) of Sweden?
Keep it short and to the point. 3.96e+09. 